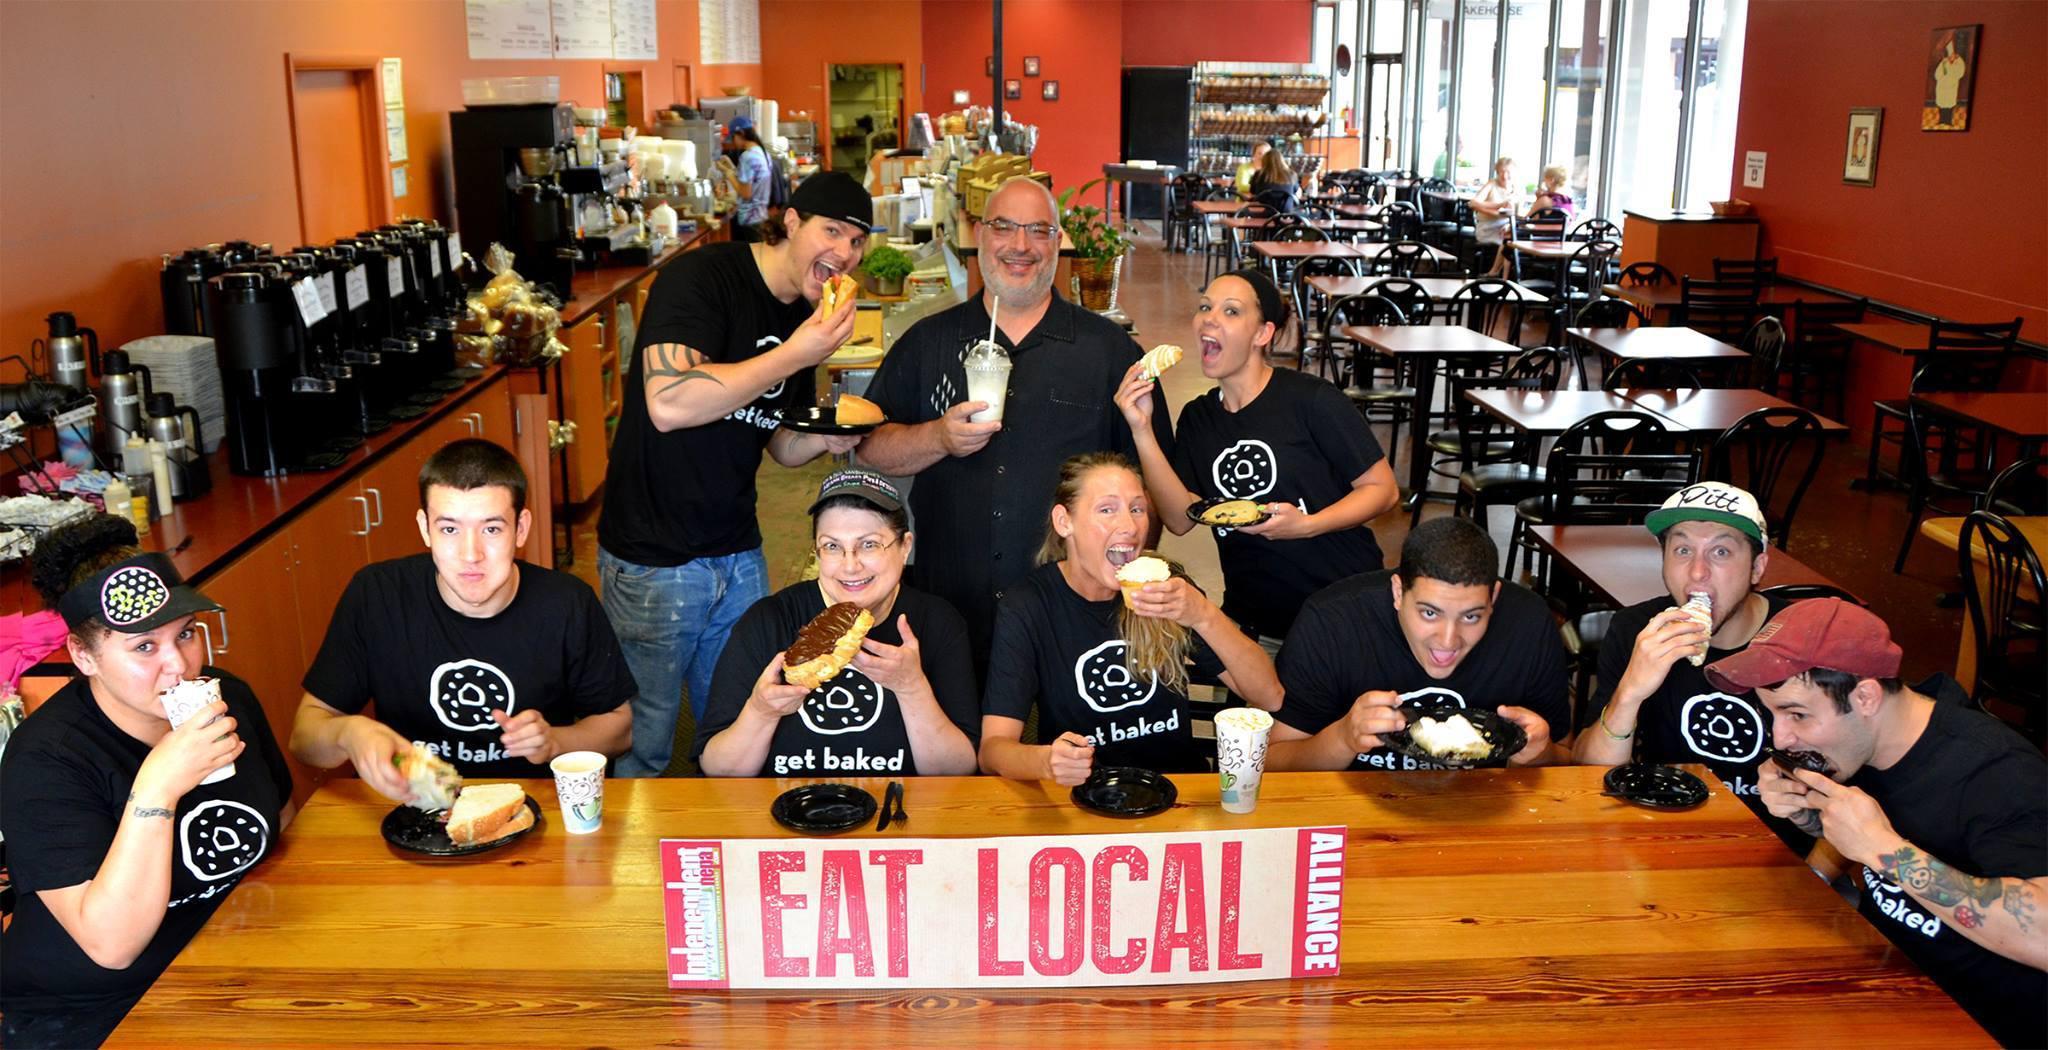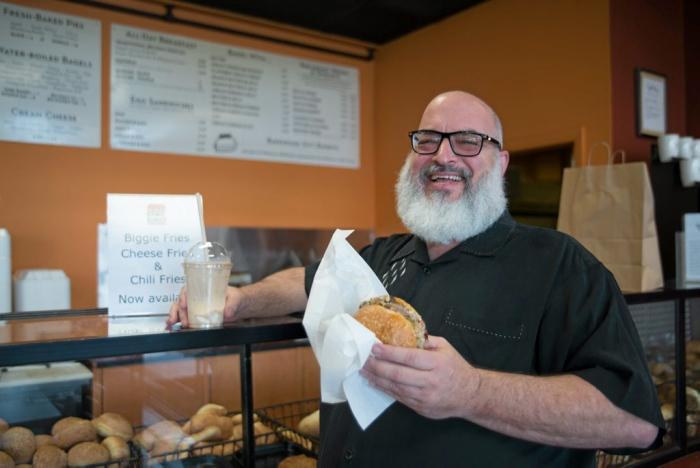The first image is the image on the left, the second image is the image on the right. For the images shown, is this caption "There are more women than there are men." true? Answer yes or no. No. The first image is the image on the left, the second image is the image on the right. Analyze the images presented: Is the assertion "Has atleast one picture of a lone bearded man" valid? Answer yes or no. Yes. 